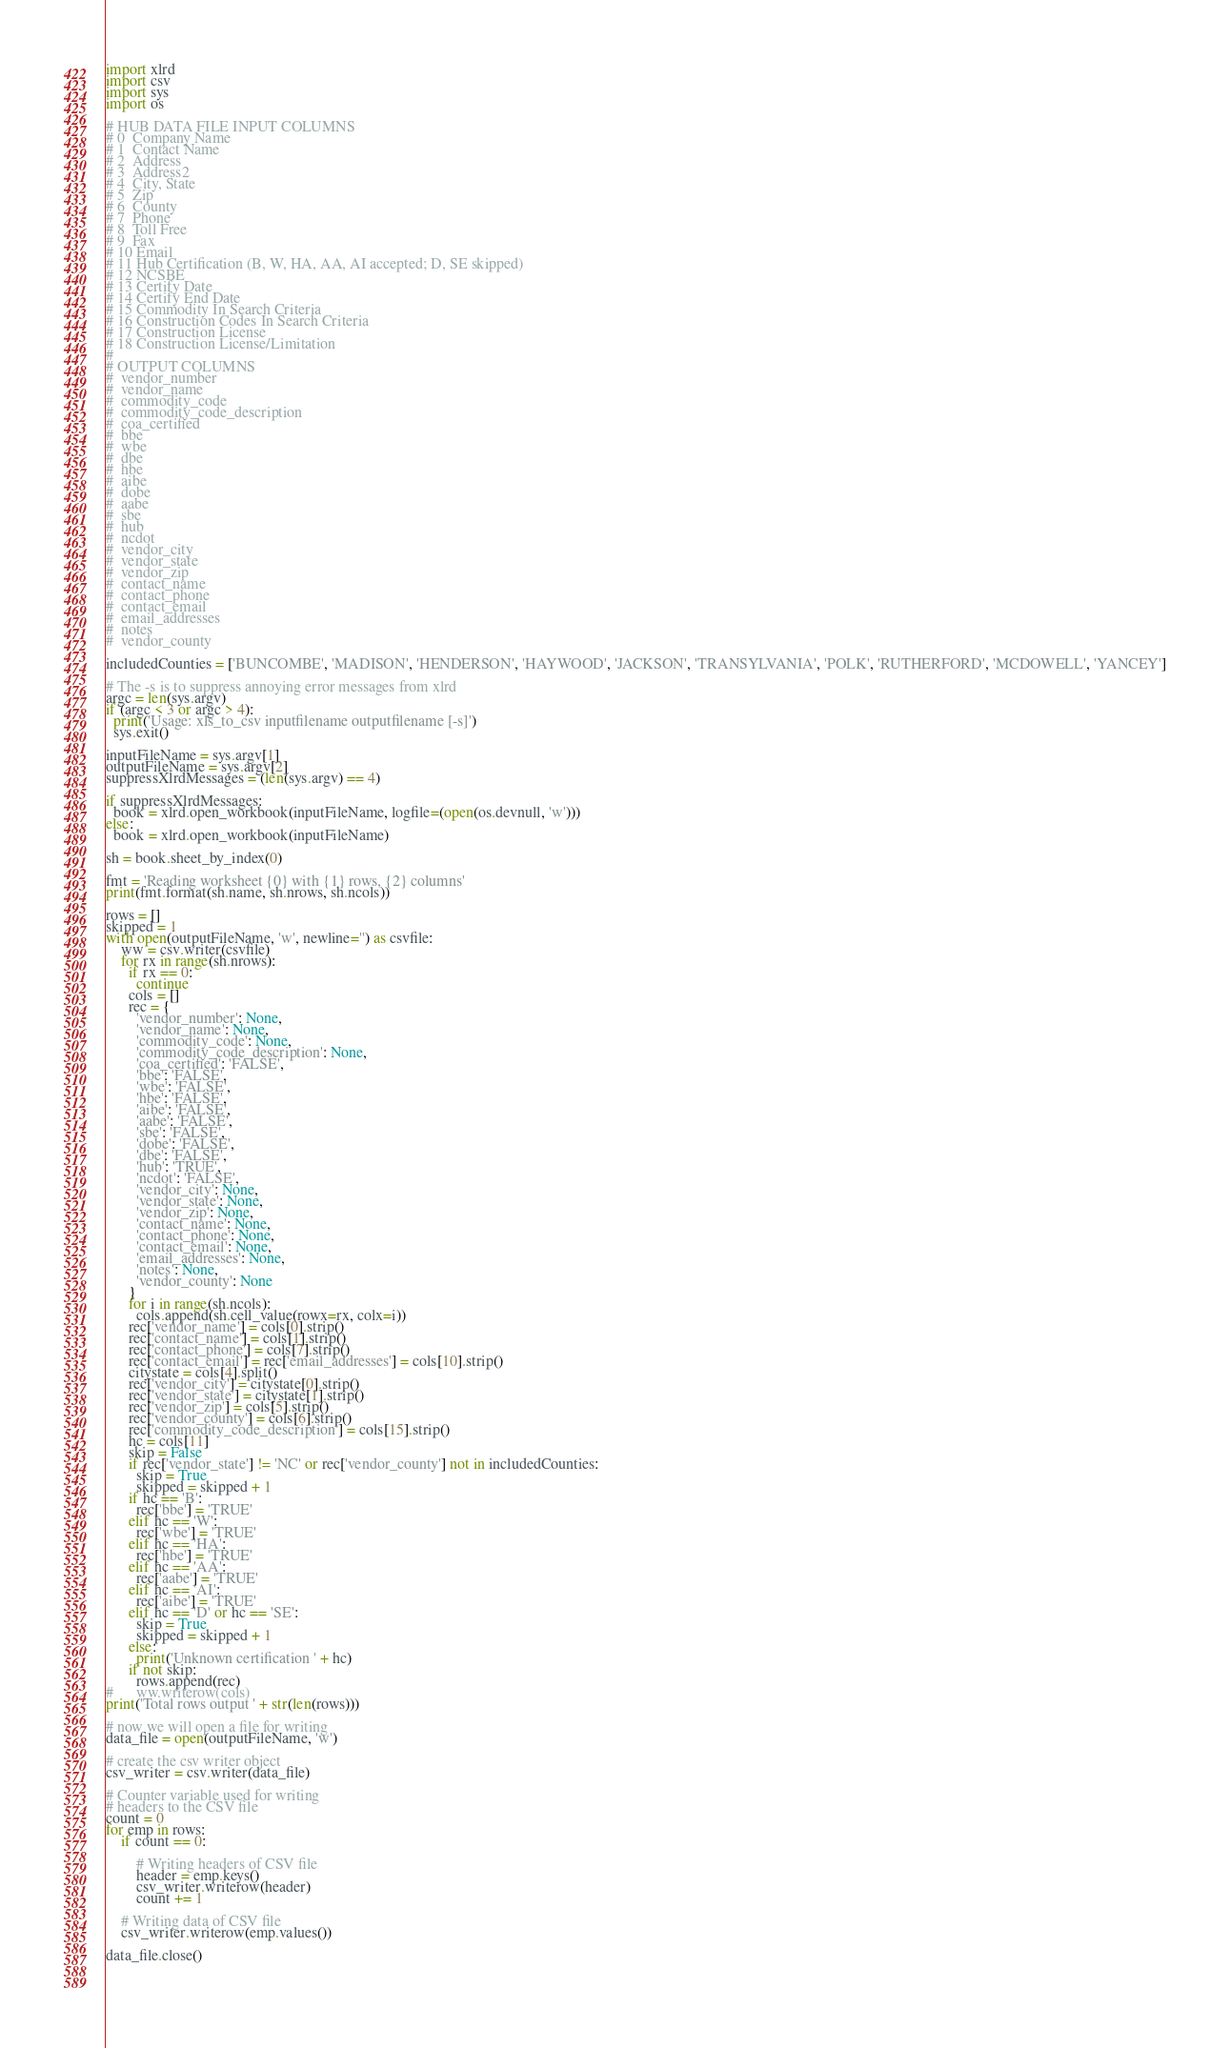Convert code to text. <code><loc_0><loc_0><loc_500><loc_500><_Python_>import xlrd
import csv
import sys
import os

# HUB DATA FILE INPUT COLUMNS
# 0  Company Name
# 1  Contact Name
# 2  Address
# 3  Address2
# 4  City, State
# 5  Zip
# 6  County
# 7  Phone
# 8  Toll Free
# 9  Fax
# 10 Email
# 11 Hub Certification (B, W, HA, AA, AI accepted; D, SE skipped)
# 12 NCSBE
# 13 Certify Date
# 14 Certify End Date
# 15 Commodity In Search Criteria
# 16 Construction Codes In Search Criteria
# 17 Construction License
# 18 Construction License/Limitation
#
# OUTPUT COLUMNS
#  vendor_number
#  vendor_name
#  commodity_code
#  commodity_code_description
#  coa_certified
#  bbe
#  wbe
#  dbe
#  hbe
#  aibe
#  dobe
#  aabe
#  sbe
#  hub
#  ncdot
#  vendor_city
#  vendor_state
#  vendor_zip
#  contact_name
#  contact_phone
#  contact_email
#  email_addresses
#  notes
#  vendor_county

includedCounties = ['BUNCOMBE', 'MADISON', 'HENDERSON', 'HAYWOOD', 'JACKSON', 'TRANSYLVANIA', 'POLK', 'RUTHERFORD', 'MCDOWELL', 'YANCEY']

# The -s is to suppress annoying error messages from xlrd
argc = len(sys.argv)
if (argc < 3 or argc > 4):
  print('Usage: xls_to_csv inputfilename outputfilename [-s]')
  sys.exit()

inputFileName = sys.argv[1]
outputFileName = sys.argv[2]
suppressXlrdMessages = (len(sys.argv) == 4)

if suppressXlrdMessages:
  book = xlrd.open_workbook(inputFileName, logfile=(open(os.devnull, 'w')))
else:
  book = xlrd.open_workbook(inputFileName)

sh = book.sheet_by_index(0)

fmt = 'Reading worksheet {0} with {1} rows, {2} columns'
print(fmt.format(sh.name, sh.nrows, sh.ncols))

rows = []
skipped = 1
with open(outputFileName, 'w', newline='') as csvfile:
    ww = csv.writer(csvfile)
    for rx in range(sh.nrows):
      if rx == 0:
        continue
      cols = []
      rec = {
        'vendor_number': None,
        'vendor_name': None,
        'commodity_code': None,
        'commodity_code_description': None,
        'coa_certified': 'FALSE',
        'bbe': 'FALSE',
        'wbe': 'FALSE',
        'hbe': 'FALSE',
        'aibe': 'FALSE',
        'aabe': 'FALSE',
        'sbe': 'FALSE',
        'dobe': 'FALSE',
        'dbe': 'FALSE',
        'hub': 'TRUE',
        'ncdot': 'FALSE',
        'vendor_city': None,
        'vendor_state': None,
        'vendor_zip': None,
        'contact_name': None,
        'contact_phone': None,
        'contact_email': None,
        'email_addresses': None,
        'notes': None,
        'vendor_county': None
      }
      for i in range(sh.ncols):
        cols.append(sh.cell_value(rowx=rx, colx=i))
      rec['vendor_name'] = cols[0].strip()
      rec['contact_name'] = cols[1].strip()
      rec['contact_phone'] = cols[7].strip()
      rec['contact_email'] = rec['email_addresses'] = cols[10].strip()
      citystate = cols[4].split()
      rec['vendor_city'] = citystate[0].strip()
      rec['vendor_state'] = citystate[1].strip()
      rec['vendor_zip'] = cols[5].strip()
      rec['vendor_county'] = cols[6].strip()
      rec['commodity_code_description'] = cols[15].strip()
      hc = cols[11]
      skip = False
      if rec['vendor_state'] != 'NC' or rec['vendor_county'] not in includedCounties:
        skip = True
        skipped = skipped + 1
      if hc == 'B':
        rec['bbe'] = 'TRUE'
      elif hc == 'W':
        rec['wbe'] = 'TRUE'
      elif hc == 'HA':
        rec['hbe'] = 'TRUE'
      elif hc == 'AA':
        rec['aabe'] = 'TRUE'
      elif hc == 'AI':
        rec['aibe'] = 'TRUE'
      elif hc == 'D' or hc == 'SE':
        skip = True
        skipped = skipped + 1
      else:
        print('Unknown certification ' + hc)
      if not skip:
        rows.append(rec)
#      ww.writerow(cols)
print('Total rows output ' + str(len(rows)))

# now we will open a file for writing
data_file = open(outputFileName, 'w')
 
# create the csv writer object
csv_writer = csv.writer(data_file)
 
# Counter variable used for writing
# headers to the CSV file
count = 0
for emp in rows:
    if count == 0:
 
        # Writing headers of CSV file
        header = emp.keys()
        csv_writer.writerow(header)
        count += 1
 
    # Writing data of CSV file
    csv_writer.writerow(emp.values())
 
data_file.close()

			

</code> 